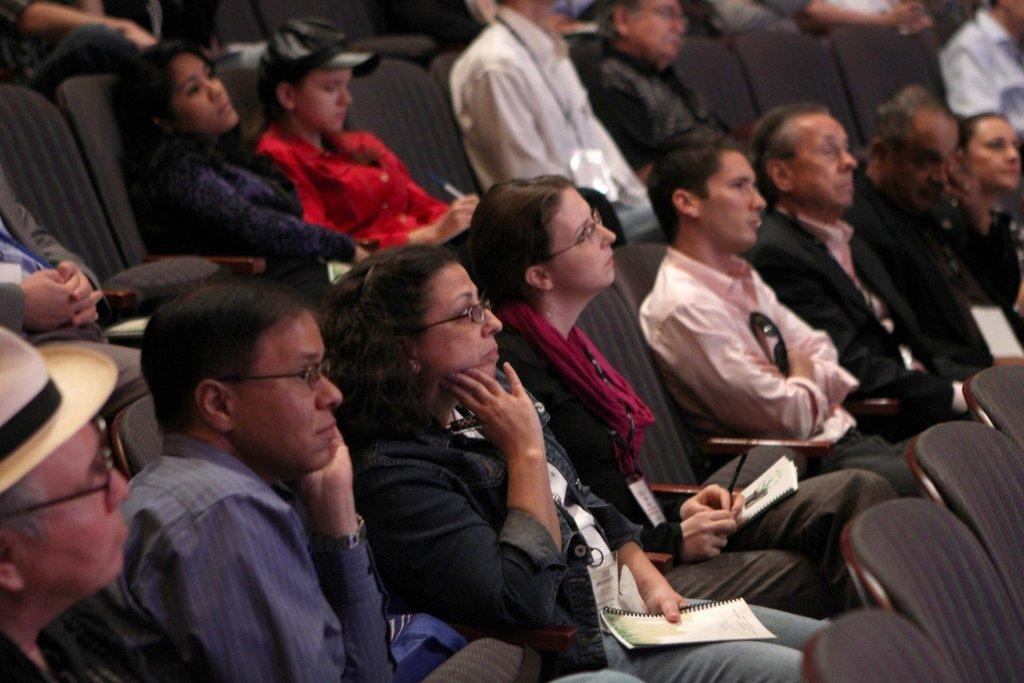What are the people in the image doing? The persons in the image are sitting on chairs. Are all the chairs occupied in the image? No, there are empty chairs in the image. Where are the persons sitting in the image? Some persons are sitting in the front of the image. What are the persons holding in their hands? The persons are holding books in their hands. What type of flowers can be seen growing on the persons in the image? There are no flowers growing on the persons in the image; they are holding books in their hands. 